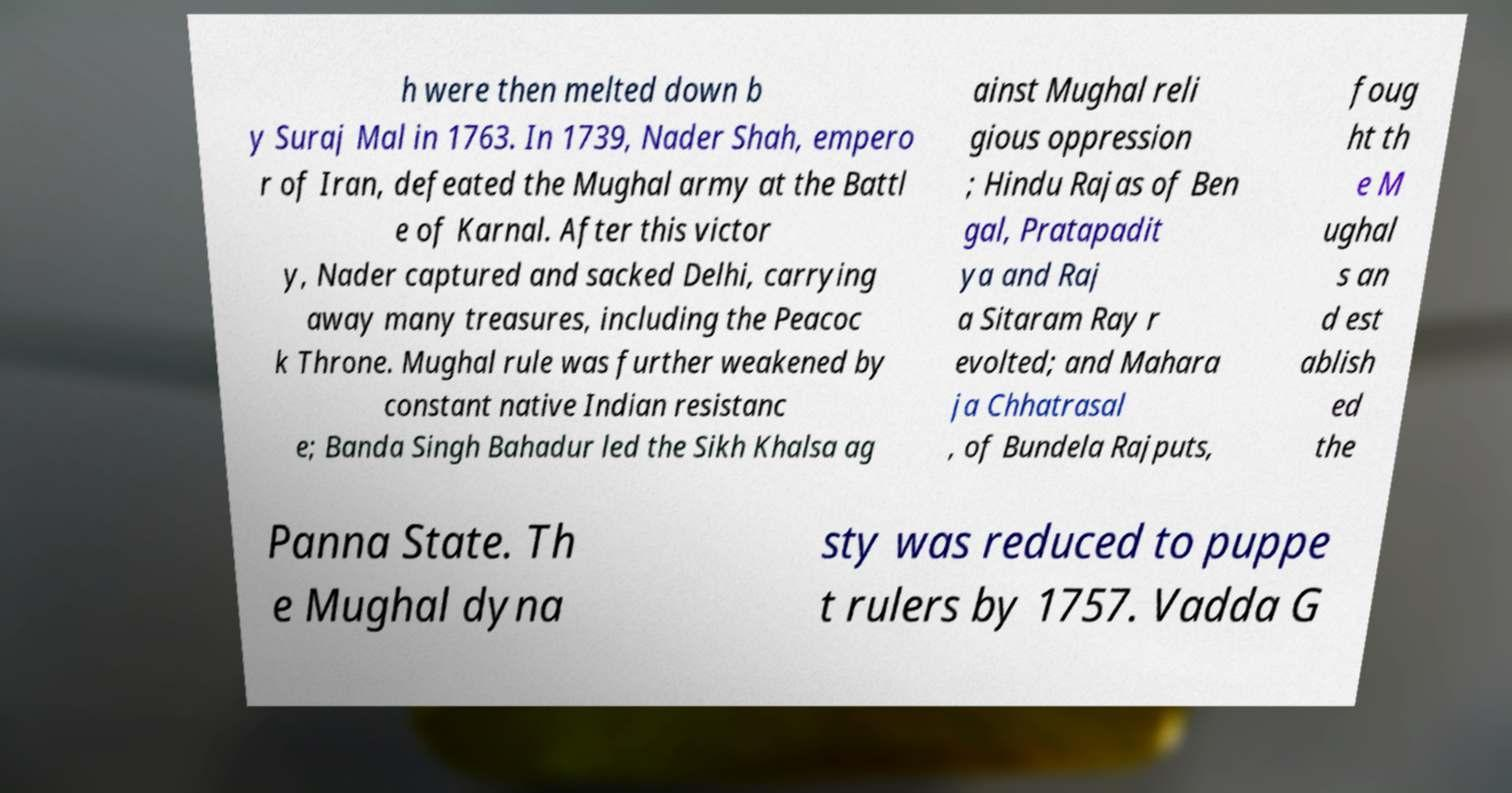Can you read and provide the text displayed in the image?This photo seems to have some interesting text. Can you extract and type it out for me? h were then melted down b y Suraj Mal in 1763. In 1739, Nader Shah, empero r of Iran, defeated the Mughal army at the Battl e of Karnal. After this victor y, Nader captured and sacked Delhi, carrying away many treasures, including the Peacoc k Throne. Mughal rule was further weakened by constant native Indian resistanc e; Banda Singh Bahadur led the Sikh Khalsa ag ainst Mughal reli gious oppression ; Hindu Rajas of Ben gal, Pratapadit ya and Raj a Sitaram Ray r evolted; and Mahara ja Chhatrasal , of Bundela Rajputs, foug ht th e M ughal s an d est ablish ed the Panna State. Th e Mughal dyna sty was reduced to puppe t rulers by 1757. Vadda G 